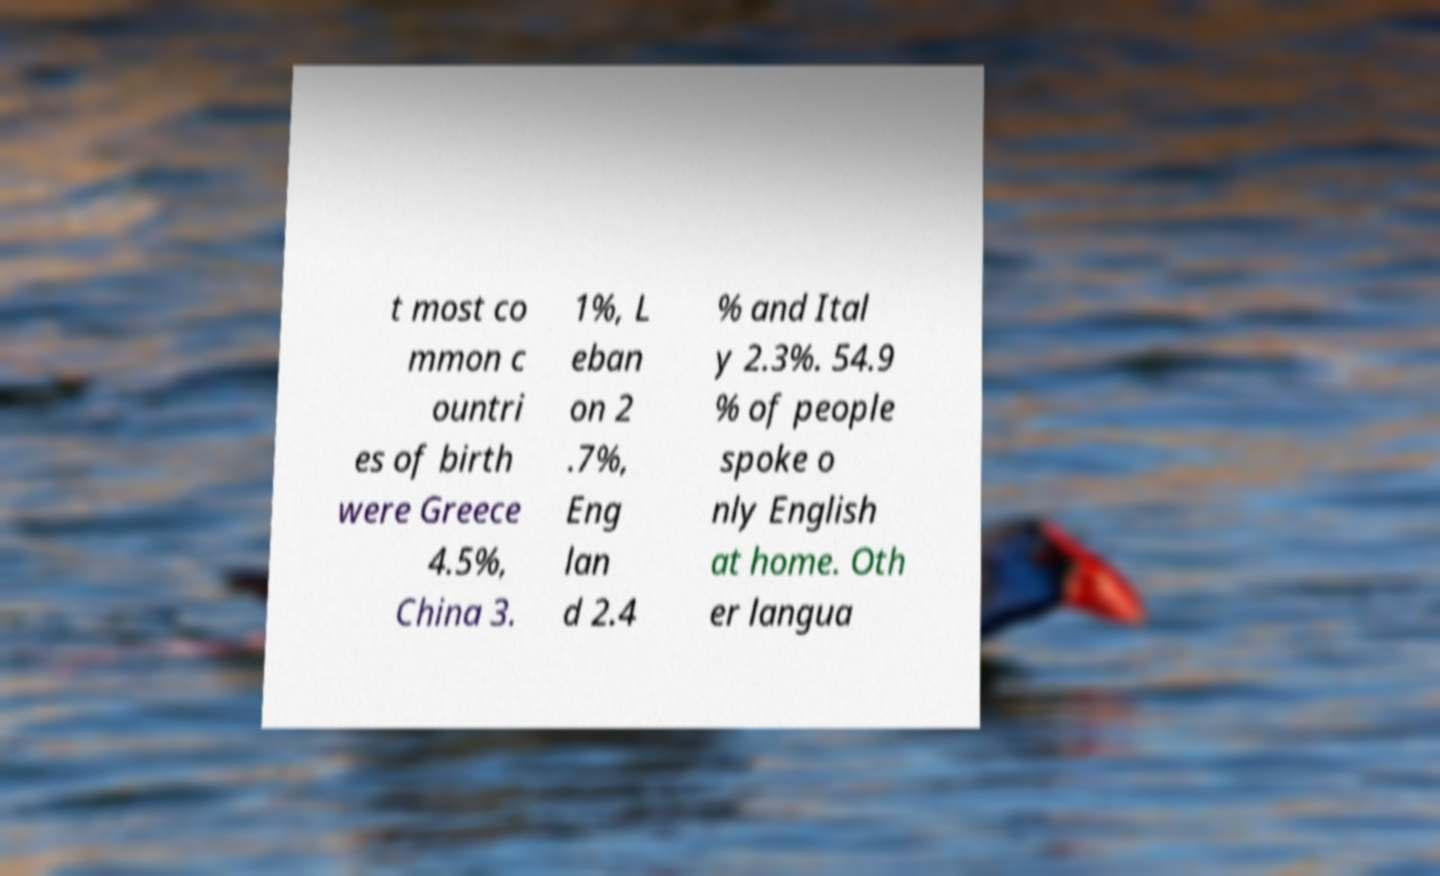What messages or text are displayed in this image? I need them in a readable, typed format. t most co mmon c ountri es of birth were Greece 4.5%, China 3. 1%, L eban on 2 .7%, Eng lan d 2.4 % and Ital y 2.3%. 54.9 % of people spoke o nly English at home. Oth er langua 